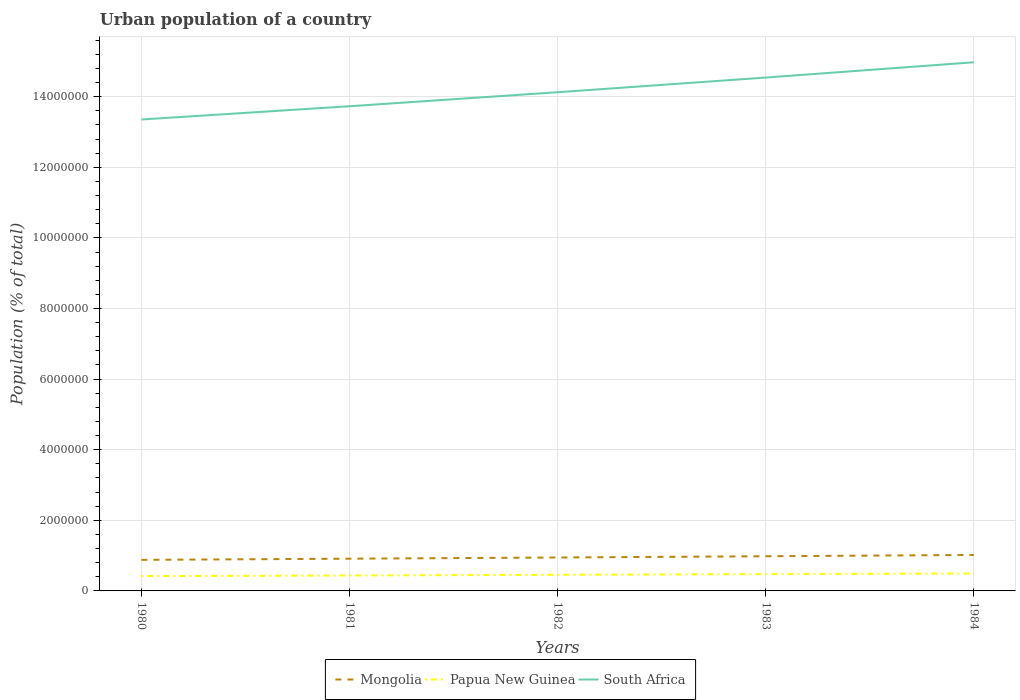Does the line corresponding to Papua New Guinea intersect with the line corresponding to Mongolia?
Keep it short and to the point. No. Is the number of lines equal to the number of legend labels?
Your answer should be compact. Yes. Across all years, what is the maximum urban population in Papua New Guinea?
Your answer should be very brief. 4.20e+05. What is the total urban population in South Africa in the graph?
Your answer should be very brief. -7.72e+05. What is the difference between the highest and the second highest urban population in South Africa?
Give a very brief answer. 1.62e+06. How many lines are there?
Offer a terse response. 3. Does the graph contain grids?
Your answer should be compact. Yes. Where does the legend appear in the graph?
Make the answer very short. Bottom center. How are the legend labels stacked?
Keep it short and to the point. Horizontal. What is the title of the graph?
Keep it short and to the point. Urban population of a country. Does "Greece" appear as one of the legend labels in the graph?
Keep it short and to the point. No. What is the label or title of the Y-axis?
Offer a very short reply. Population (% of total). What is the Population (% of total) in Mongolia in 1980?
Keep it short and to the point. 8.80e+05. What is the Population (% of total) in Papua New Guinea in 1980?
Provide a short and direct response. 4.20e+05. What is the Population (% of total) in South Africa in 1980?
Provide a short and direct response. 1.34e+07. What is the Population (% of total) in Mongolia in 1981?
Your answer should be very brief. 9.13e+05. What is the Population (% of total) in Papua New Guinea in 1981?
Provide a succinct answer. 4.38e+05. What is the Population (% of total) in South Africa in 1981?
Keep it short and to the point. 1.37e+07. What is the Population (% of total) of Mongolia in 1982?
Ensure brevity in your answer.  9.47e+05. What is the Population (% of total) in Papua New Guinea in 1982?
Your response must be concise. 4.56e+05. What is the Population (% of total) in South Africa in 1982?
Provide a short and direct response. 1.41e+07. What is the Population (% of total) in Mongolia in 1983?
Offer a terse response. 9.82e+05. What is the Population (% of total) of Papua New Guinea in 1983?
Provide a short and direct response. 4.75e+05. What is the Population (% of total) in South Africa in 1983?
Keep it short and to the point. 1.45e+07. What is the Population (% of total) in Mongolia in 1984?
Keep it short and to the point. 1.02e+06. What is the Population (% of total) of Papua New Guinea in 1984?
Your answer should be compact. 4.95e+05. What is the Population (% of total) of South Africa in 1984?
Your answer should be compact. 1.50e+07. Across all years, what is the maximum Population (% of total) of Mongolia?
Offer a very short reply. 1.02e+06. Across all years, what is the maximum Population (% of total) in Papua New Guinea?
Give a very brief answer. 4.95e+05. Across all years, what is the maximum Population (% of total) of South Africa?
Offer a terse response. 1.50e+07. Across all years, what is the minimum Population (% of total) in Mongolia?
Your answer should be compact. 8.80e+05. Across all years, what is the minimum Population (% of total) in Papua New Guinea?
Your answer should be very brief. 4.20e+05. Across all years, what is the minimum Population (% of total) in South Africa?
Ensure brevity in your answer.  1.34e+07. What is the total Population (% of total) in Mongolia in the graph?
Provide a succinct answer. 4.74e+06. What is the total Population (% of total) in Papua New Guinea in the graph?
Provide a succinct answer. 2.28e+06. What is the total Population (% of total) in South Africa in the graph?
Offer a terse response. 7.07e+07. What is the difference between the Population (% of total) of Mongolia in 1980 and that in 1981?
Provide a succinct answer. -3.31e+04. What is the difference between the Population (% of total) in Papua New Guinea in 1980 and that in 1981?
Provide a succinct answer. -1.80e+04. What is the difference between the Population (% of total) of South Africa in 1980 and that in 1981?
Your response must be concise. -3.76e+05. What is the difference between the Population (% of total) of Mongolia in 1980 and that in 1982?
Your answer should be compact. -6.70e+04. What is the difference between the Population (% of total) in Papua New Guinea in 1980 and that in 1982?
Keep it short and to the point. -3.65e+04. What is the difference between the Population (% of total) in South Africa in 1980 and that in 1982?
Ensure brevity in your answer.  -7.72e+05. What is the difference between the Population (% of total) of Mongolia in 1980 and that in 1983?
Your response must be concise. -1.02e+05. What is the difference between the Population (% of total) in Papua New Guinea in 1980 and that in 1983?
Offer a terse response. -5.56e+04. What is the difference between the Population (% of total) of South Africa in 1980 and that in 1983?
Your answer should be very brief. -1.19e+06. What is the difference between the Population (% of total) of Mongolia in 1980 and that in 1984?
Give a very brief answer. -1.39e+05. What is the difference between the Population (% of total) of Papua New Guinea in 1980 and that in 1984?
Give a very brief answer. -7.52e+04. What is the difference between the Population (% of total) of South Africa in 1980 and that in 1984?
Your response must be concise. -1.62e+06. What is the difference between the Population (% of total) of Mongolia in 1981 and that in 1982?
Give a very brief answer. -3.38e+04. What is the difference between the Population (% of total) in Papua New Guinea in 1981 and that in 1982?
Your answer should be compact. -1.84e+04. What is the difference between the Population (% of total) of South Africa in 1981 and that in 1982?
Offer a very short reply. -3.96e+05. What is the difference between the Population (% of total) in Mongolia in 1981 and that in 1983?
Offer a terse response. -6.89e+04. What is the difference between the Population (% of total) in Papua New Guinea in 1981 and that in 1983?
Provide a short and direct response. -3.76e+04. What is the difference between the Population (% of total) in South Africa in 1981 and that in 1983?
Keep it short and to the point. -8.12e+05. What is the difference between the Population (% of total) in Mongolia in 1981 and that in 1984?
Your answer should be compact. -1.06e+05. What is the difference between the Population (% of total) of Papua New Guinea in 1981 and that in 1984?
Provide a succinct answer. -5.72e+04. What is the difference between the Population (% of total) in South Africa in 1981 and that in 1984?
Offer a terse response. -1.25e+06. What is the difference between the Population (% of total) of Mongolia in 1982 and that in 1983?
Your response must be concise. -3.50e+04. What is the difference between the Population (% of total) of Papua New Guinea in 1982 and that in 1983?
Your answer should be compact. -1.91e+04. What is the difference between the Population (% of total) of South Africa in 1982 and that in 1983?
Your answer should be very brief. -4.16e+05. What is the difference between the Population (% of total) in Mongolia in 1982 and that in 1984?
Ensure brevity in your answer.  -7.19e+04. What is the difference between the Population (% of total) of Papua New Guinea in 1982 and that in 1984?
Keep it short and to the point. -3.88e+04. What is the difference between the Population (% of total) of South Africa in 1982 and that in 1984?
Your answer should be compact. -8.49e+05. What is the difference between the Population (% of total) in Mongolia in 1983 and that in 1984?
Your answer should be compact. -3.69e+04. What is the difference between the Population (% of total) in Papua New Guinea in 1983 and that in 1984?
Make the answer very short. -1.96e+04. What is the difference between the Population (% of total) in South Africa in 1983 and that in 1984?
Give a very brief answer. -4.33e+05. What is the difference between the Population (% of total) of Mongolia in 1980 and the Population (% of total) of Papua New Guinea in 1981?
Your answer should be very brief. 4.42e+05. What is the difference between the Population (% of total) of Mongolia in 1980 and the Population (% of total) of South Africa in 1981?
Make the answer very short. -1.28e+07. What is the difference between the Population (% of total) of Papua New Guinea in 1980 and the Population (% of total) of South Africa in 1981?
Offer a terse response. -1.33e+07. What is the difference between the Population (% of total) in Mongolia in 1980 and the Population (% of total) in Papua New Guinea in 1982?
Ensure brevity in your answer.  4.24e+05. What is the difference between the Population (% of total) of Mongolia in 1980 and the Population (% of total) of South Africa in 1982?
Make the answer very short. -1.32e+07. What is the difference between the Population (% of total) of Papua New Guinea in 1980 and the Population (% of total) of South Africa in 1982?
Your response must be concise. -1.37e+07. What is the difference between the Population (% of total) in Mongolia in 1980 and the Population (% of total) in Papua New Guinea in 1983?
Give a very brief answer. 4.05e+05. What is the difference between the Population (% of total) in Mongolia in 1980 and the Population (% of total) in South Africa in 1983?
Offer a terse response. -1.37e+07. What is the difference between the Population (% of total) of Papua New Guinea in 1980 and the Population (% of total) of South Africa in 1983?
Your answer should be very brief. -1.41e+07. What is the difference between the Population (% of total) in Mongolia in 1980 and the Population (% of total) in Papua New Guinea in 1984?
Your answer should be compact. 3.85e+05. What is the difference between the Population (% of total) of Mongolia in 1980 and the Population (% of total) of South Africa in 1984?
Your answer should be compact. -1.41e+07. What is the difference between the Population (% of total) in Papua New Guinea in 1980 and the Population (% of total) in South Africa in 1984?
Offer a terse response. -1.46e+07. What is the difference between the Population (% of total) in Mongolia in 1981 and the Population (% of total) in Papua New Guinea in 1982?
Make the answer very short. 4.57e+05. What is the difference between the Population (% of total) of Mongolia in 1981 and the Population (% of total) of South Africa in 1982?
Your response must be concise. -1.32e+07. What is the difference between the Population (% of total) of Papua New Guinea in 1981 and the Population (% of total) of South Africa in 1982?
Offer a terse response. -1.37e+07. What is the difference between the Population (% of total) in Mongolia in 1981 and the Population (% of total) in Papua New Guinea in 1983?
Offer a terse response. 4.38e+05. What is the difference between the Population (% of total) of Mongolia in 1981 and the Population (% of total) of South Africa in 1983?
Give a very brief answer. -1.36e+07. What is the difference between the Population (% of total) of Papua New Guinea in 1981 and the Population (% of total) of South Africa in 1983?
Make the answer very short. -1.41e+07. What is the difference between the Population (% of total) of Mongolia in 1981 and the Population (% of total) of Papua New Guinea in 1984?
Give a very brief answer. 4.18e+05. What is the difference between the Population (% of total) of Mongolia in 1981 and the Population (% of total) of South Africa in 1984?
Make the answer very short. -1.41e+07. What is the difference between the Population (% of total) in Papua New Guinea in 1981 and the Population (% of total) in South Africa in 1984?
Your response must be concise. -1.45e+07. What is the difference between the Population (% of total) of Mongolia in 1982 and the Population (% of total) of Papua New Guinea in 1983?
Offer a very short reply. 4.72e+05. What is the difference between the Population (% of total) in Mongolia in 1982 and the Population (% of total) in South Africa in 1983?
Provide a short and direct response. -1.36e+07. What is the difference between the Population (% of total) in Papua New Guinea in 1982 and the Population (% of total) in South Africa in 1983?
Your response must be concise. -1.41e+07. What is the difference between the Population (% of total) in Mongolia in 1982 and the Population (% of total) in Papua New Guinea in 1984?
Make the answer very short. 4.52e+05. What is the difference between the Population (% of total) of Mongolia in 1982 and the Population (% of total) of South Africa in 1984?
Ensure brevity in your answer.  -1.40e+07. What is the difference between the Population (% of total) of Papua New Guinea in 1982 and the Population (% of total) of South Africa in 1984?
Offer a very short reply. -1.45e+07. What is the difference between the Population (% of total) of Mongolia in 1983 and the Population (% of total) of Papua New Guinea in 1984?
Provide a succinct answer. 4.87e+05. What is the difference between the Population (% of total) of Mongolia in 1983 and the Population (% of total) of South Africa in 1984?
Offer a terse response. -1.40e+07. What is the difference between the Population (% of total) of Papua New Guinea in 1983 and the Population (% of total) of South Africa in 1984?
Your answer should be very brief. -1.45e+07. What is the average Population (% of total) of Mongolia per year?
Your answer should be very brief. 9.48e+05. What is the average Population (% of total) in Papua New Guinea per year?
Ensure brevity in your answer.  4.57e+05. What is the average Population (% of total) of South Africa per year?
Offer a very short reply. 1.41e+07. In the year 1980, what is the difference between the Population (% of total) in Mongolia and Population (% of total) in Papua New Guinea?
Ensure brevity in your answer.  4.60e+05. In the year 1980, what is the difference between the Population (% of total) in Mongolia and Population (% of total) in South Africa?
Provide a short and direct response. -1.25e+07. In the year 1980, what is the difference between the Population (% of total) in Papua New Guinea and Population (% of total) in South Africa?
Offer a very short reply. -1.29e+07. In the year 1981, what is the difference between the Population (% of total) in Mongolia and Population (% of total) in Papua New Guinea?
Offer a very short reply. 4.76e+05. In the year 1981, what is the difference between the Population (% of total) in Mongolia and Population (% of total) in South Africa?
Provide a succinct answer. -1.28e+07. In the year 1981, what is the difference between the Population (% of total) of Papua New Guinea and Population (% of total) of South Africa?
Your answer should be very brief. -1.33e+07. In the year 1982, what is the difference between the Population (% of total) of Mongolia and Population (% of total) of Papua New Guinea?
Make the answer very short. 4.91e+05. In the year 1982, what is the difference between the Population (% of total) of Mongolia and Population (% of total) of South Africa?
Ensure brevity in your answer.  -1.32e+07. In the year 1982, what is the difference between the Population (% of total) of Papua New Guinea and Population (% of total) of South Africa?
Give a very brief answer. -1.37e+07. In the year 1983, what is the difference between the Population (% of total) of Mongolia and Population (% of total) of Papua New Guinea?
Your response must be concise. 5.07e+05. In the year 1983, what is the difference between the Population (% of total) in Mongolia and Population (% of total) in South Africa?
Give a very brief answer. -1.36e+07. In the year 1983, what is the difference between the Population (% of total) in Papua New Guinea and Population (% of total) in South Africa?
Provide a short and direct response. -1.41e+07. In the year 1984, what is the difference between the Population (% of total) in Mongolia and Population (% of total) in Papua New Guinea?
Give a very brief answer. 5.24e+05. In the year 1984, what is the difference between the Population (% of total) of Mongolia and Population (% of total) of South Africa?
Offer a very short reply. -1.40e+07. In the year 1984, what is the difference between the Population (% of total) in Papua New Guinea and Population (% of total) in South Africa?
Keep it short and to the point. -1.45e+07. What is the ratio of the Population (% of total) of Mongolia in 1980 to that in 1981?
Make the answer very short. 0.96. What is the ratio of the Population (% of total) in Papua New Guinea in 1980 to that in 1981?
Your response must be concise. 0.96. What is the ratio of the Population (% of total) of South Africa in 1980 to that in 1981?
Give a very brief answer. 0.97. What is the ratio of the Population (% of total) of Mongolia in 1980 to that in 1982?
Provide a short and direct response. 0.93. What is the ratio of the Population (% of total) in Papua New Guinea in 1980 to that in 1982?
Your answer should be very brief. 0.92. What is the ratio of the Population (% of total) of South Africa in 1980 to that in 1982?
Give a very brief answer. 0.95. What is the ratio of the Population (% of total) in Mongolia in 1980 to that in 1983?
Offer a very short reply. 0.9. What is the ratio of the Population (% of total) in Papua New Guinea in 1980 to that in 1983?
Provide a succinct answer. 0.88. What is the ratio of the Population (% of total) in South Africa in 1980 to that in 1983?
Your response must be concise. 0.92. What is the ratio of the Population (% of total) in Mongolia in 1980 to that in 1984?
Keep it short and to the point. 0.86. What is the ratio of the Population (% of total) of Papua New Guinea in 1980 to that in 1984?
Your answer should be very brief. 0.85. What is the ratio of the Population (% of total) in South Africa in 1980 to that in 1984?
Your response must be concise. 0.89. What is the ratio of the Population (% of total) of Mongolia in 1981 to that in 1982?
Provide a succinct answer. 0.96. What is the ratio of the Population (% of total) of Papua New Guinea in 1981 to that in 1982?
Offer a terse response. 0.96. What is the ratio of the Population (% of total) of South Africa in 1981 to that in 1982?
Ensure brevity in your answer.  0.97. What is the ratio of the Population (% of total) in Mongolia in 1981 to that in 1983?
Offer a very short reply. 0.93. What is the ratio of the Population (% of total) of Papua New Guinea in 1981 to that in 1983?
Give a very brief answer. 0.92. What is the ratio of the Population (% of total) of South Africa in 1981 to that in 1983?
Give a very brief answer. 0.94. What is the ratio of the Population (% of total) of Mongolia in 1981 to that in 1984?
Provide a succinct answer. 0.9. What is the ratio of the Population (% of total) of Papua New Guinea in 1981 to that in 1984?
Ensure brevity in your answer.  0.88. What is the ratio of the Population (% of total) of South Africa in 1981 to that in 1984?
Your response must be concise. 0.92. What is the ratio of the Population (% of total) of Mongolia in 1982 to that in 1983?
Your answer should be very brief. 0.96. What is the ratio of the Population (% of total) of Papua New Guinea in 1982 to that in 1983?
Provide a succinct answer. 0.96. What is the ratio of the Population (% of total) of South Africa in 1982 to that in 1983?
Offer a very short reply. 0.97. What is the ratio of the Population (% of total) in Mongolia in 1982 to that in 1984?
Your answer should be compact. 0.93. What is the ratio of the Population (% of total) in Papua New Guinea in 1982 to that in 1984?
Your response must be concise. 0.92. What is the ratio of the Population (% of total) of South Africa in 1982 to that in 1984?
Give a very brief answer. 0.94. What is the ratio of the Population (% of total) of Mongolia in 1983 to that in 1984?
Make the answer very short. 0.96. What is the ratio of the Population (% of total) of Papua New Guinea in 1983 to that in 1984?
Your response must be concise. 0.96. What is the ratio of the Population (% of total) of South Africa in 1983 to that in 1984?
Provide a succinct answer. 0.97. What is the difference between the highest and the second highest Population (% of total) of Mongolia?
Make the answer very short. 3.69e+04. What is the difference between the highest and the second highest Population (% of total) in Papua New Guinea?
Your answer should be compact. 1.96e+04. What is the difference between the highest and the second highest Population (% of total) of South Africa?
Your answer should be very brief. 4.33e+05. What is the difference between the highest and the lowest Population (% of total) of Mongolia?
Make the answer very short. 1.39e+05. What is the difference between the highest and the lowest Population (% of total) of Papua New Guinea?
Ensure brevity in your answer.  7.52e+04. What is the difference between the highest and the lowest Population (% of total) of South Africa?
Provide a succinct answer. 1.62e+06. 